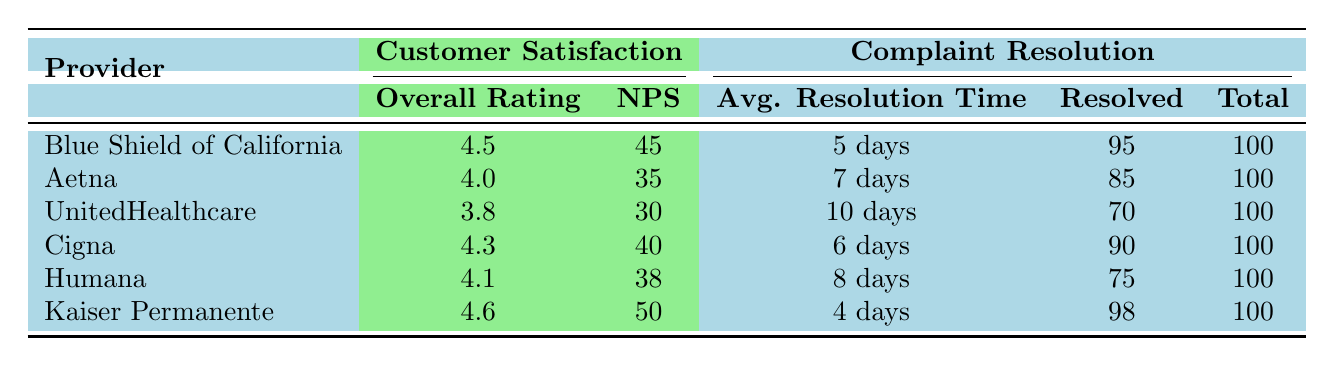What is the overall rating of Kaiser Permanente? The table indicates that the overall rating for Kaiser Permanente is listed in the "Customer Satisfaction" section, specifically under "Overall Rating." This value is 4.6.
Answer: 4.6 Which health insurance provider has the highest Net Promoter Score (NPS)? By comparing the NPS values for each provider in the "Customer Satisfaction" section, Kaiser Permanente has the highest NPS at 50.
Answer: Kaiser Permanente What is the average resolution time for complaints at Cigna? The table lists the average resolution time for Cigna under the "Complaint Resolution" section, which is 6 days.
Answer: 6 days Which provider resolved the highest percentage of complaints? To determine this, we look at the "Complaints Resolved" and "Total Complaints" columns for each provider. Kaiser Permanente resolved 98 out of 100 complaints, which is 98%. Thus, it has the highest percentage.
Answer: Kaiser Permanente How many total complaints did UnitedHealthcare have? UnitedHealthcare's total complaints are shown in the "Complaint Resolution" section under "Total Complaints." The total is 100.
Answer: 100 What is the average overall rating of all providers? To find the average overall rating, add all the overall ratings (4.5 + 4.0 + 3.8 + 4.3 + 4.1 + 4.6 = 25.3) and divide by 6 (the number of providers). The average overall rating is 25.3 / 6 = 4.2167, approximately 4.22.
Answer: 4.22 Is the average resolution time for complaints shorter for Kaiser Permanente than for Aetna? The average resolution time for Kaiser Permanente is 4 days and for Aetna is 7 days. Since 4 days is less than 7 days, the statement is true.
Answer: Yes Which provider has the lowest overall rating? By looking at the "Customer Satisfaction" section, the provider with the lowest overall rating is UnitedHealthcare, with a rating of 3.8.
Answer: UnitedHealthcare What is the difference in NPS between Blue Shield of California and Cigna? The NPS for Blue Shield of California is 45, and for Cigna, it is 40. The difference is calculated as 45 - 40 = 5.
Answer: 5 Which provider had an average resolution time longer than 7 days? The average resolution times for each provider are compared. Of all providers, only UnitedHealthcare has an average resolution time of 10 days, which is longer than 7 days.
Answer: UnitedHealthcare If you combine the complaints resolved by Blue Shield of California and Cigna, what is the total? Blue Shield of California resolved 95 complaints and Cigna resolved 90. Adding these together gives a total of 95 + 90 = 185 resolved complaints.
Answer: 185 